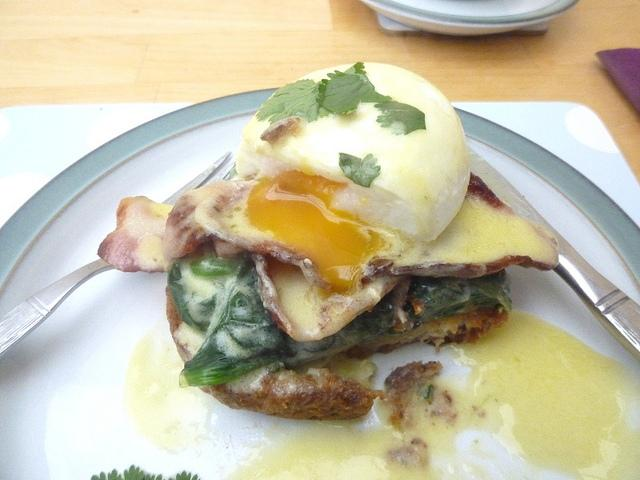What is near the top of the food pile? egg 